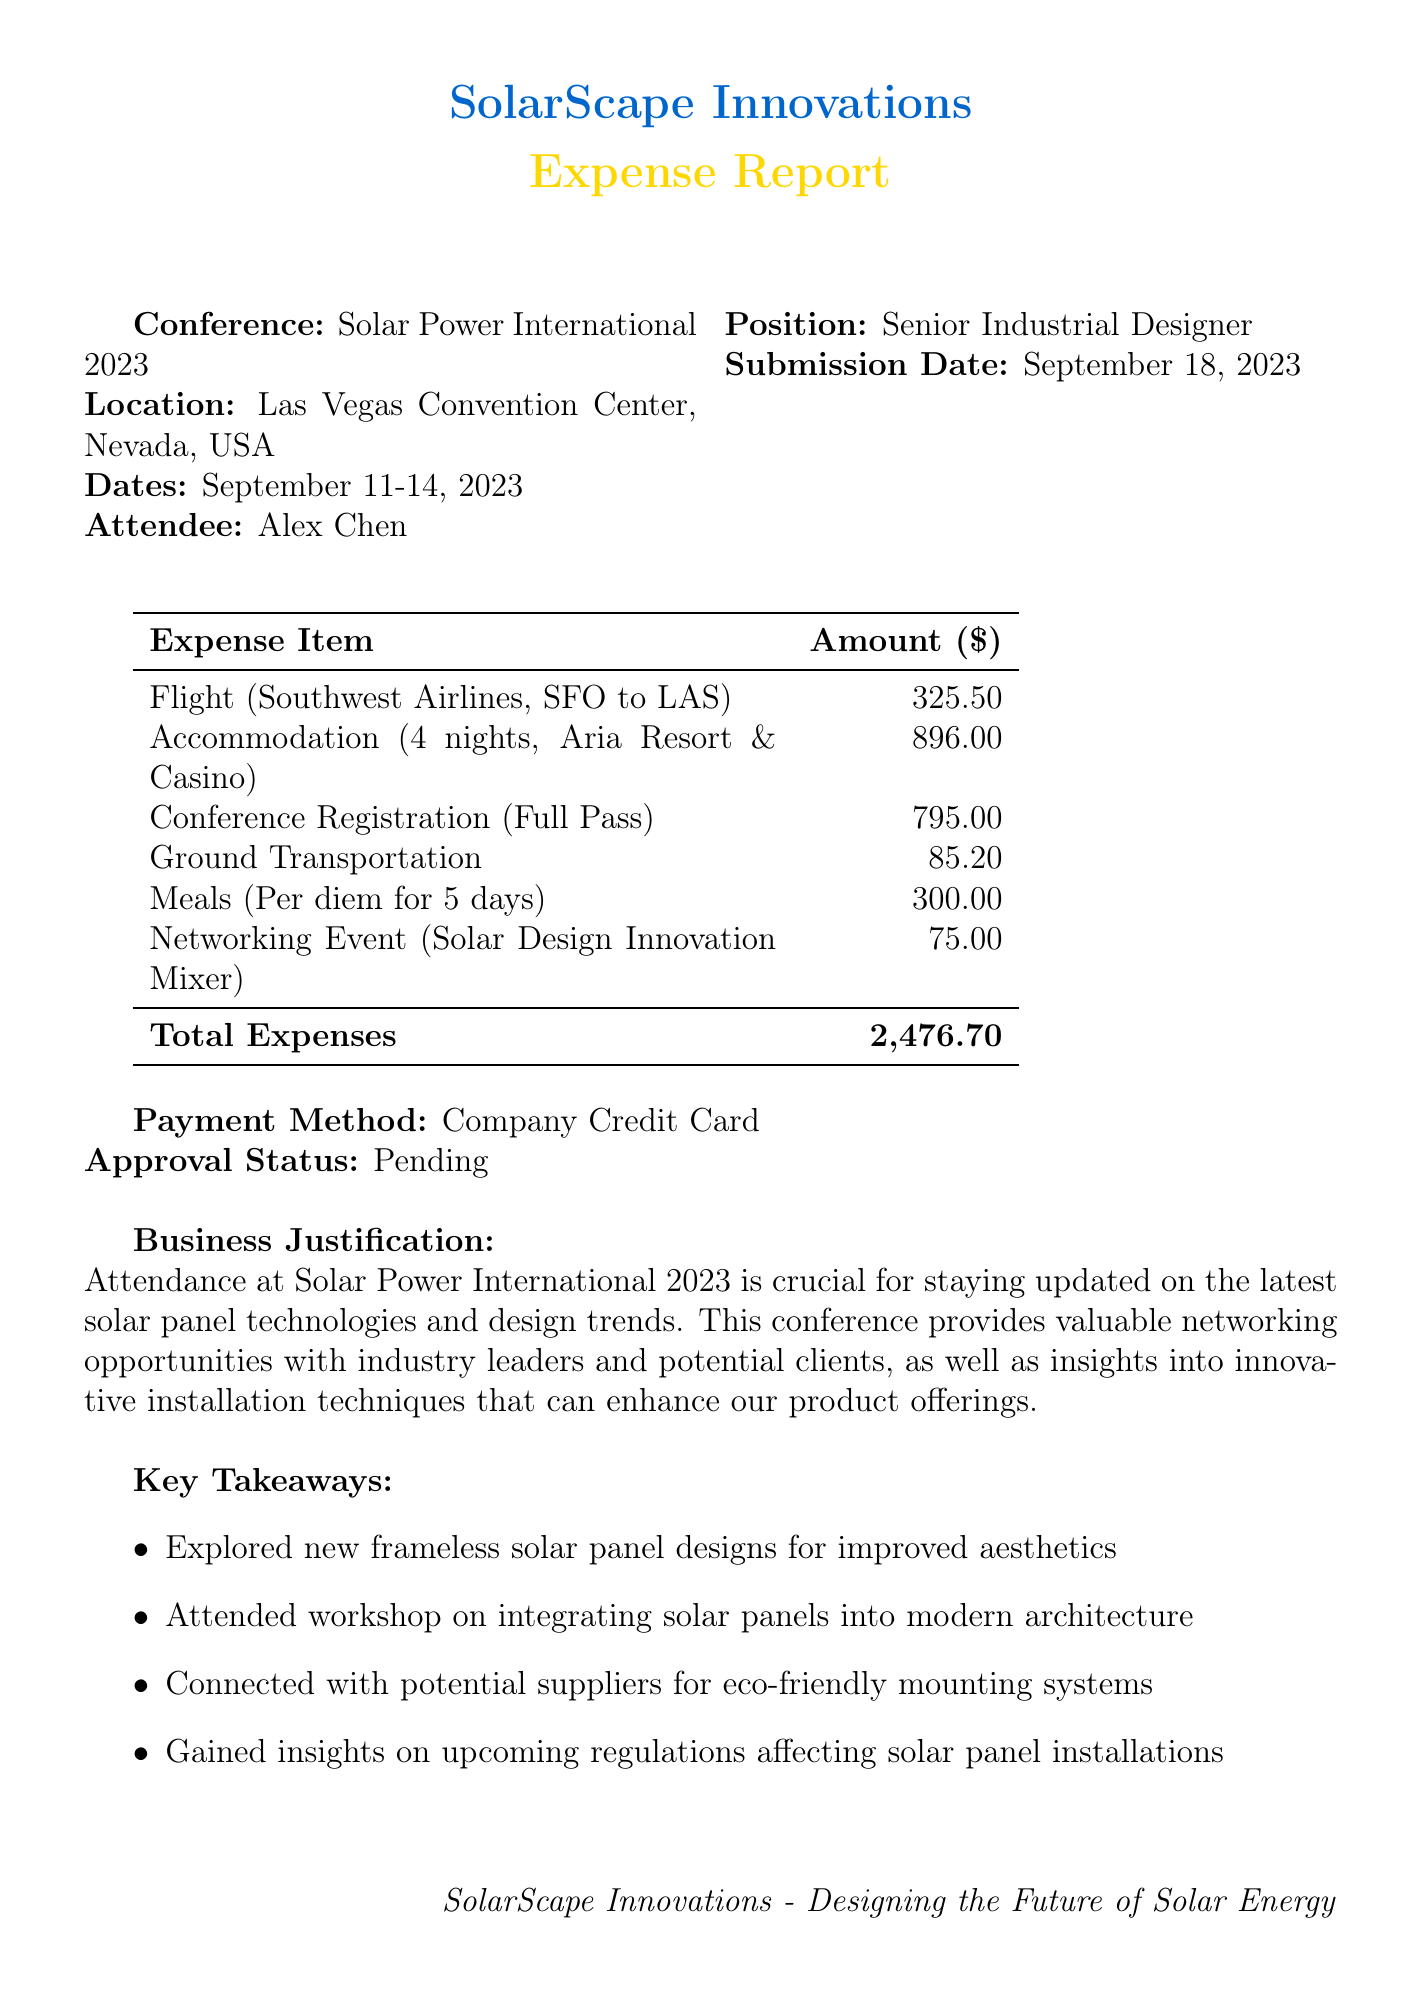What is the conference name? The conference name is mentioned in the document as part of the event details.
Answer: Solar Power International 2023 What is the total amount of expenses? The total expenses are calculated by summing all listed expense items.
Answer: 2,476.70 Who is the attendee? The document specifies the name of the person attending the conference.
Answer: Alex Chen What is the check-out date for accommodation? The check-out date is listed in the accommodation details of the expense report.
Answer: September 14, 2023 What was the registration fee for the conference? The fee is stated under the Conference Registration expense item.
Answer: 795.00 Why is attendance at the conference justified? The business justification provides a reasoning for the expense report.
Answer: Staying updated on latest solar panel technologies What airline was used for the flight? The specific airline for the flight is detailed in the flight expense item.
Answer: Southwest Airlines What method of payment was used for the expenses? The method of payment is specified in the expense report.
Answer: Company Credit Card How many nights did the accommodation last? The number of nights is detailed in the accommodation description.
Answer: 4 nights 